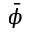Convert formula to latex. <formula><loc_0><loc_0><loc_500><loc_500>\bar { \phi }</formula> 